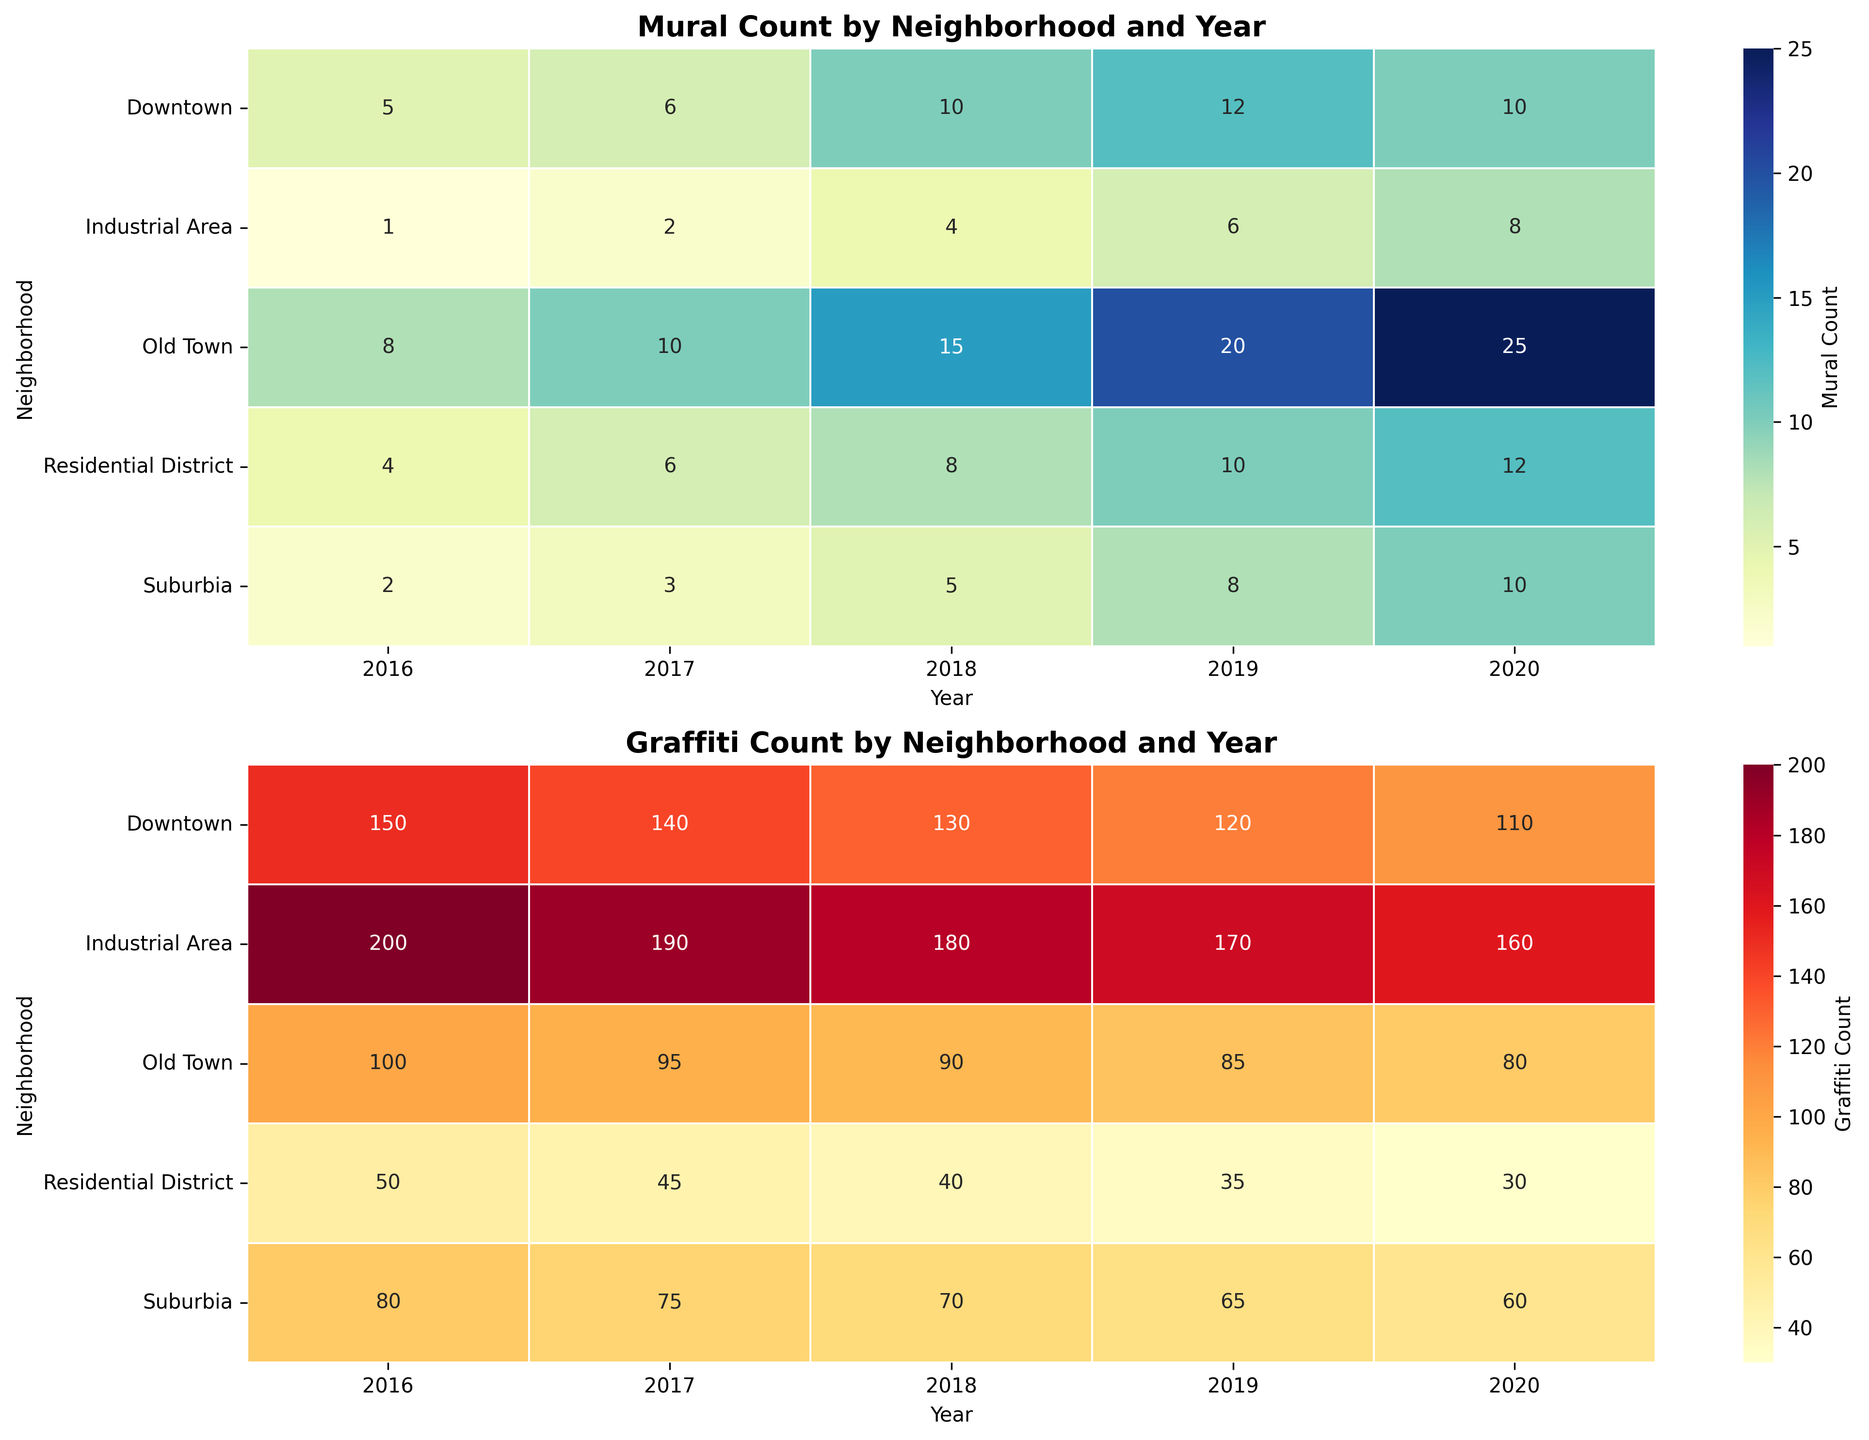What's the neighborhood with the highest count of murals in 2020? Look at the heatmap for mural counts in the year 2020 and identify the highest value. The highest count is 25 which occurs in Old Town.
Answer: Old Town Which year saw the largest reduction in graffiti counts in Downtown? Compare the graffiti counts in Downtown across the years. The count dropped from 150 in 2016 to 140 in 2017, a reduction of 10. Further reductions occur as the counts decrease each year, but the largest drop is the initial reduction of 10.
Answer: 2017 What is the total mural count in the Industrial Area from 2016 to 2020? Sum the mural counts in the Industrial Area from 2016 to 2020: 1+2+4 + 6 + 8 = 21.
Answer: 21 Did any neighborhood show an increase in both graffiti and mural counts in every year from 2016 to 2020? Check each neighborhood’s graffiti and mural counts year by year. Only the Industrial Area consistently increased both graffiti and mural counts over these years.
Answer: Industrial Area Which neighborhood had the lowest graffiti count in 2018? Look at the graffiti heatmap for the year 2018 and find the lowest count. The lowest count is 40 in the Residential District.
Answer: Residential District What is the average mural count in Suburbia from 2016 to 2020? Calculate the sum of mural counts in Suburbia (2 + 3 + 5 + 8 + 10) and divide by the number of years (5). The average is (2 + 3 + 5 + 8 + 10) / 5 = 5.6.
Answer: 5.6 Compare the mural counts in Old Town and Residential District in 2020. Which is higher? Look at the mural counts in Old Town (25) and Residential District (12) for the year 2020. Old Town has a higher count.
Answer: Old Town How did the graffiti count change in Suburbia from 2017 to 2018? Compare the graffiti counts in Suburbia for 2017 (75) and 2018 (70). The count decreased by 5.
Answer: Decreased by 5 Which year had the highest total number of murals across all neighborhoods? Sum the mural counts for all neighborhoods for each year. For instance, for 2020: 10 + 10 + 25 + 8 + 12 = 65. Do this for all years to see that 2020 had the highest total.
Answer: 2020 Describe the color change for graffiti counts in the Industrial Area from 2016 to 2020. Observe the color gradient in the Industrial Area part of the graffiti heatmap. It shifts from a darker red in 2016 (200) to a lighter red in 2020 (160), indicating decreasing counts.
Answer: From darker red to lighter red 